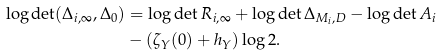Convert formula to latex. <formula><loc_0><loc_0><loc_500><loc_500>\log \det ( \Delta _ { i , \infty } , \Delta _ { 0 } ) & = \log \det R _ { i , \infty } + \log \det \Delta _ { M _ { i } , D } - \log \det A _ { i } \\ & - ( \zeta _ { Y } ( 0 ) + h _ { Y } ) \log 2 .</formula> 